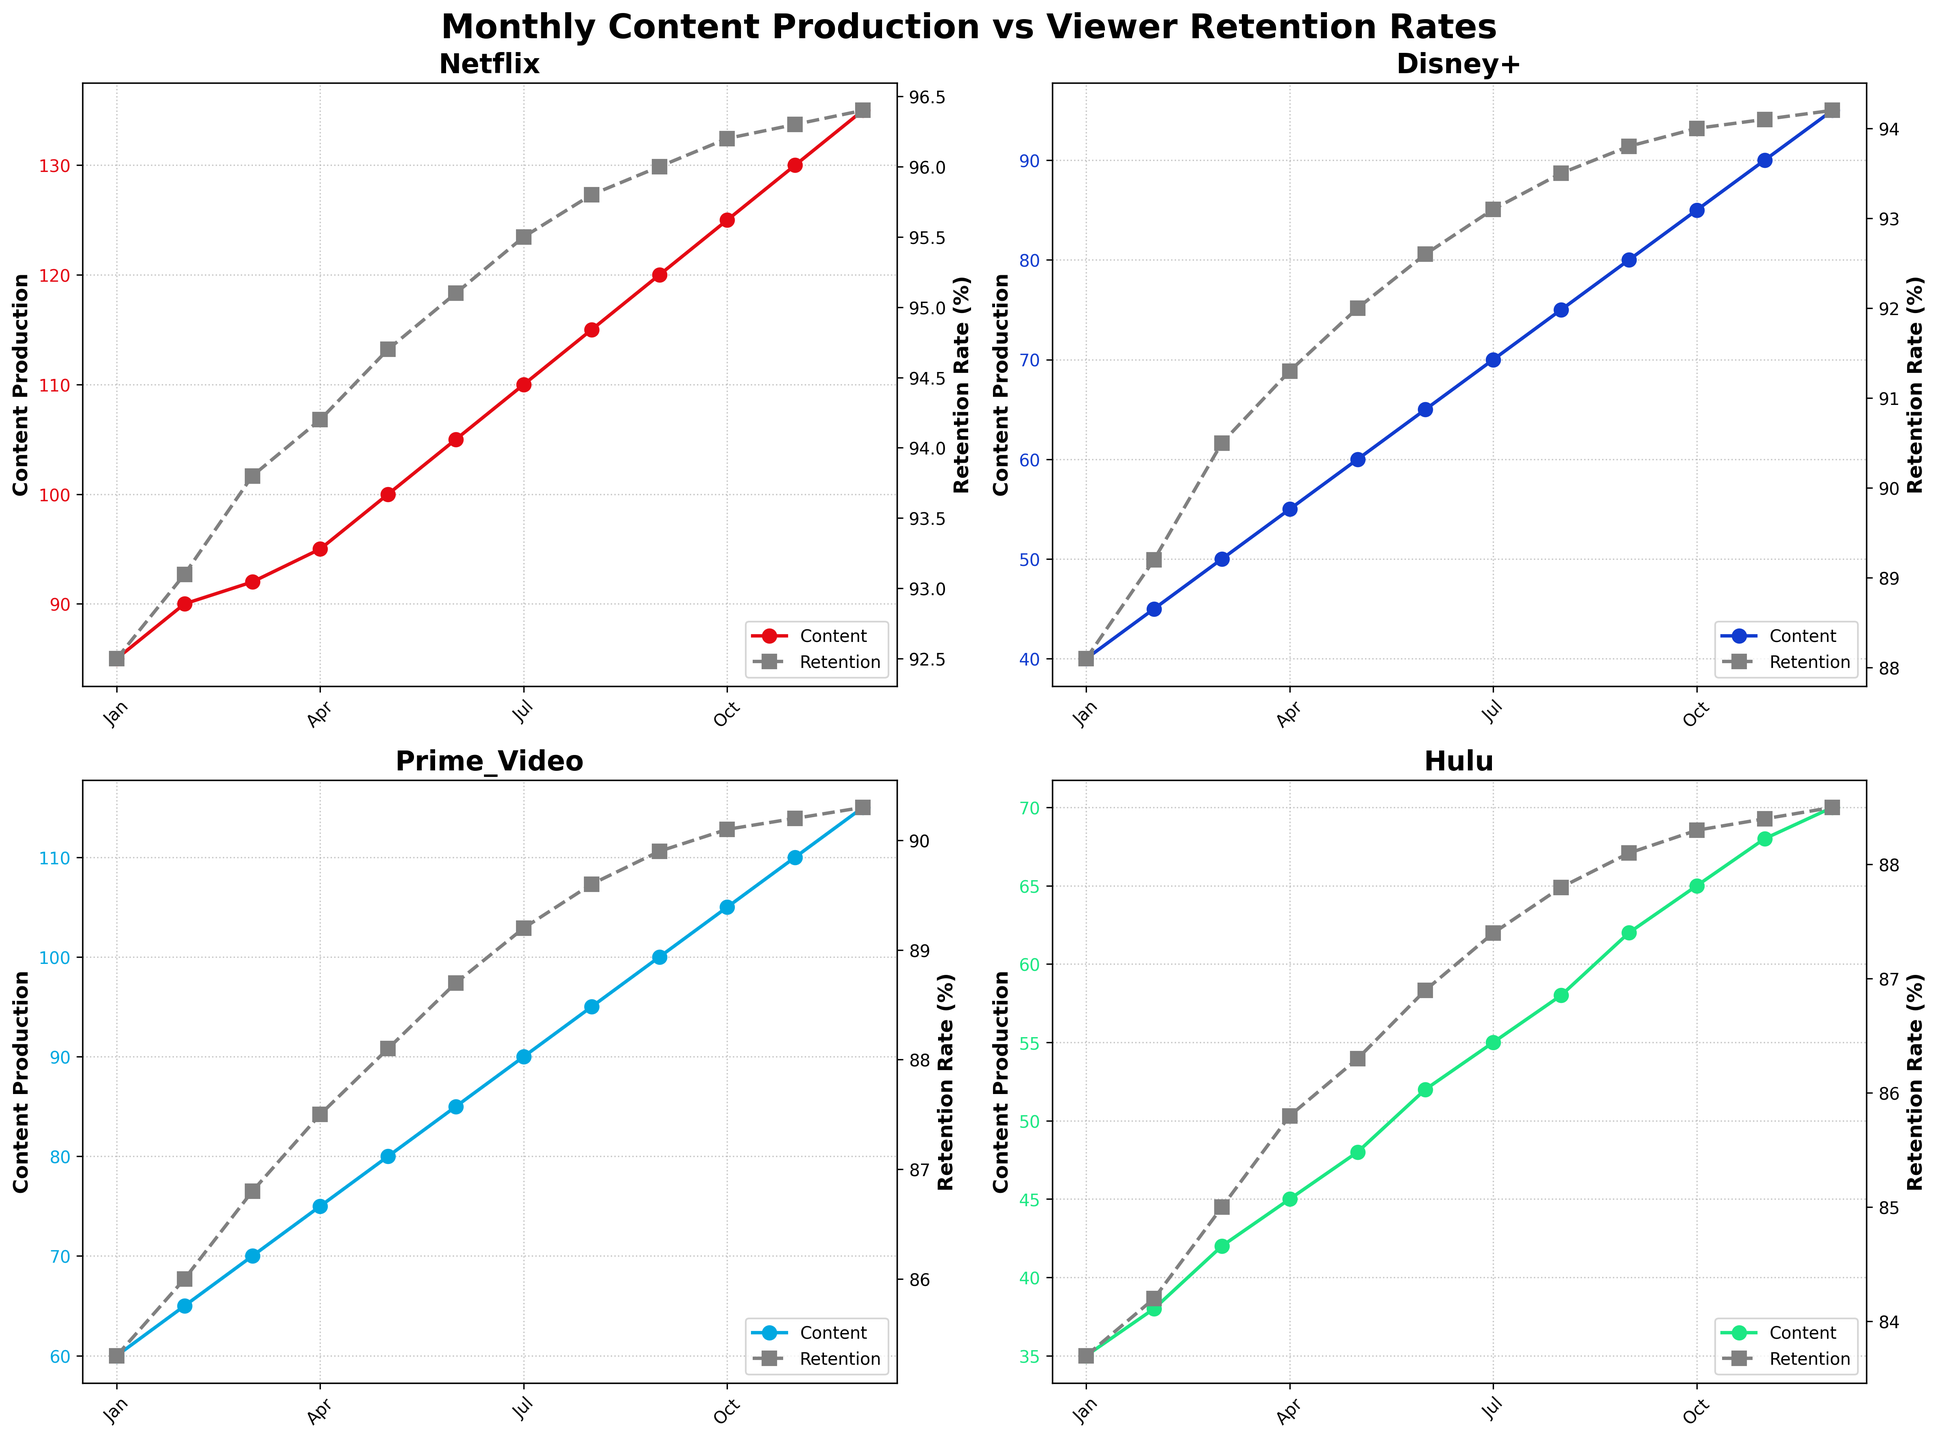What are the colors used for the line representing content production for Netflix and Disney+? Netflix uses red, and Disney+ uses blue, as indicated by the colors of their respective lines in the figure.
Answer: Red and blue Which streaming service had the highest content production in December? To find the answer, look at the content production line in December for each subplot. Netflix shows the highest value at 135.
Answer: Netflix How does the retention rate for Hulu in October compare to that in August? Look at the retention rate data points in the Hulu subplot for October and August, which are 88.3% in October and 87.8% in August. Compare these two values.
Answer: October is slightly higher What is the average content production for Prime Video over the first three months? Add the content production values for Prime Video for January, February, and March, then divide by 3: (60 + 65 + 70) / 3 = 65.
Answer: 65 Which month saw the highest retention rate for Disney+? Look for the highest data point on Disney+'s retention rate line; it is December, with a retention rate of 94.2%.
Answer: December How does Netflix's content growth from January to June compare with Hulu's? Calculate the difference for Netflix and Hulu between January and June: Netflix (105 - 85 = 20), Hulu (52 - 35 = 17). Netflix grew by 20, while Hulu grew by 17.
Answer: Netflix grew more Between April and May, which streaming service experienced the highest increase in viewer retention, and what was the increase? Compare the retention rate differences between April and May for all services: Netflix (94.7 - 94.2 = 0.5), Disney+ (92.0 - 91.3 = 0.7), Prime Video (88.1 - 87.5 = 0.6), and Hulu (86.3 - 85.8 = 0.5). Disney+ had the highest increase of 0.7.
Answer: Disney+, 0.7 What is the trend in content production for all services throughout the year? The content production for all services shows a consistent month-to-month increase across the entire year. Identify this by observing the positive slope in all content production lines.
Answer: Increasing Is there a month where the retention rate trend flattens significantly for Netflix? The retention line for Netflix is mostly increasing, but analyzing carefully, you observe April, May, and June where the increase is minimal, especially smoother between May and June.
Answer: May How does the content production in September for Prime Video compare to that of Netflix? In September, Prime Video's content production is 100, whereas Netflix's is 120, making Netflix's content production higher.
Answer: Netflix is higher 